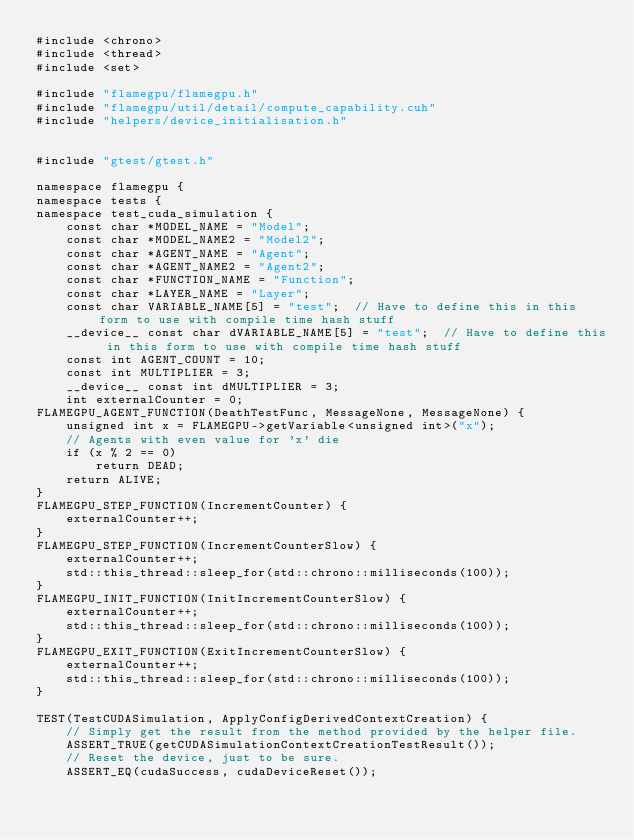Convert code to text. <code><loc_0><loc_0><loc_500><loc_500><_Cuda_>#include <chrono>
#include <thread>
#include <set>

#include "flamegpu/flamegpu.h"
#include "flamegpu/util/detail/compute_capability.cuh"
#include "helpers/device_initialisation.h"


#include "gtest/gtest.h"

namespace flamegpu {
namespace tests {
namespace test_cuda_simulation {
    const char *MODEL_NAME = "Model";
    const char *MODEL_NAME2 = "Model2";
    const char *AGENT_NAME = "Agent";
    const char *AGENT_NAME2 = "Agent2";
    const char *FUNCTION_NAME = "Function";
    const char *LAYER_NAME = "Layer";
    const char VARIABLE_NAME[5] = "test";  // Have to define this in this form to use with compile time hash stuff
    __device__ const char dVARIABLE_NAME[5] = "test";  // Have to define this in this form to use with compile time hash stuff
    const int AGENT_COUNT = 10;
    const int MULTIPLIER = 3;
    __device__ const int dMULTIPLIER = 3;
    int externalCounter = 0;
FLAMEGPU_AGENT_FUNCTION(DeathTestFunc, MessageNone, MessageNone) {
    unsigned int x = FLAMEGPU->getVariable<unsigned int>("x");
    // Agents with even value for 'x' die
    if (x % 2 == 0)
        return DEAD;
    return ALIVE;
}
FLAMEGPU_STEP_FUNCTION(IncrementCounter) {
    externalCounter++;
}
FLAMEGPU_STEP_FUNCTION(IncrementCounterSlow) {
    externalCounter++;
    std::this_thread::sleep_for(std::chrono::milliseconds(100));
}
FLAMEGPU_INIT_FUNCTION(InitIncrementCounterSlow) {
    externalCounter++;
    std::this_thread::sleep_for(std::chrono::milliseconds(100));
}
FLAMEGPU_EXIT_FUNCTION(ExitIncrementCounterSlow) {
    externalCounter++;
    std::this_thread::sleep_for(std::chrono::milliseconds(100));
}

TEST(TestCUDASimulation, ApplyConfigDerivedContextCreation) {
    // Simply get the result from the method provided by the helper file.
    ASSERT_TRUE(getCUDASimulationContextCreationTestResult());
    // Reset the device, just to be sure.
    ASSERT_EQ(cudaSuccess, cudaDeviceReset());</code> 